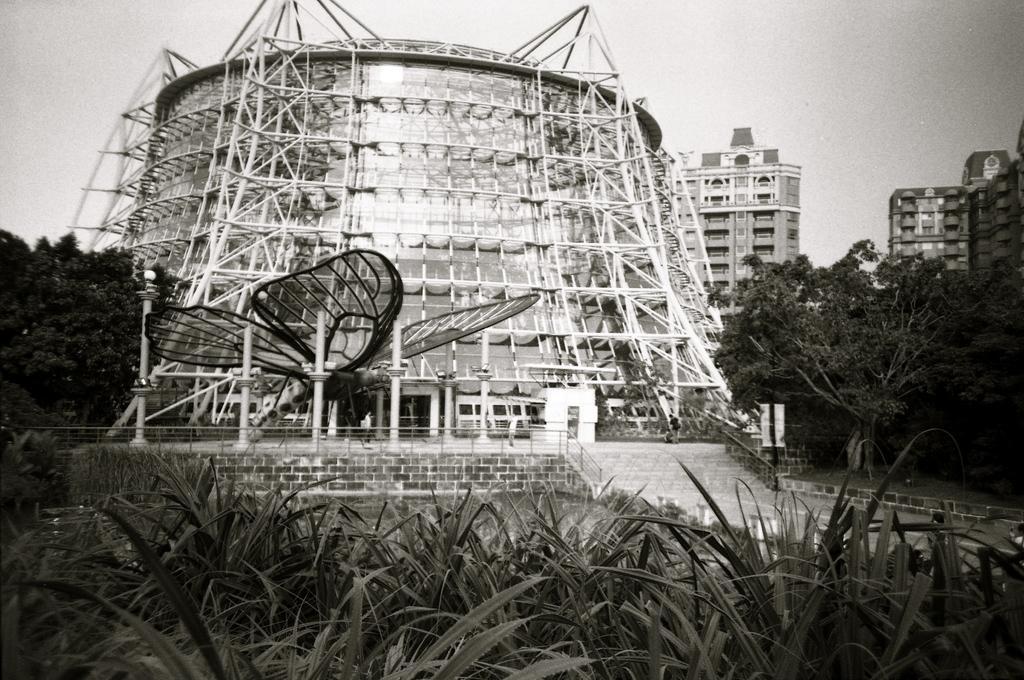Can you describe this image briefly? In this image I can see the black and white picture in which I can see few plants, few stairs, the railing, few persons standing, a huge butterfly shaped structure, few trees and few buildings. In the background I can see the sky. 